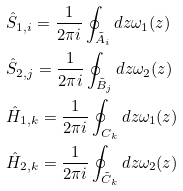<formula> <loc_0><loc_0><loc_500><loc_500>& \hat { S } _ { 1 , i } = \frac { 1 } { 2 \pi i } \oint _ { \tilde { A } _ { i } } d z \omega _ { 1 } ( z ) \\ & \hat { S } _ { 2 , j } = \frac { 1 } { 2 \pi i } \oint _ { \tilde { B } _ { j } } d z \omega _ { 2 } ( z ) \\ & \hat { H } _ { 1 , k } = \frac { 1 } { 2 \pi i } \oint _ { C _ { k } } d z \omega _ { 1 } ( z ) \\ & \hat { H } _ { 2 , k } = \frac { 1 } { 2 \pi i } \oint _ { \tilde { C } _ { k } } d z \omega _ { 2 } ( z ) \\</formula> 